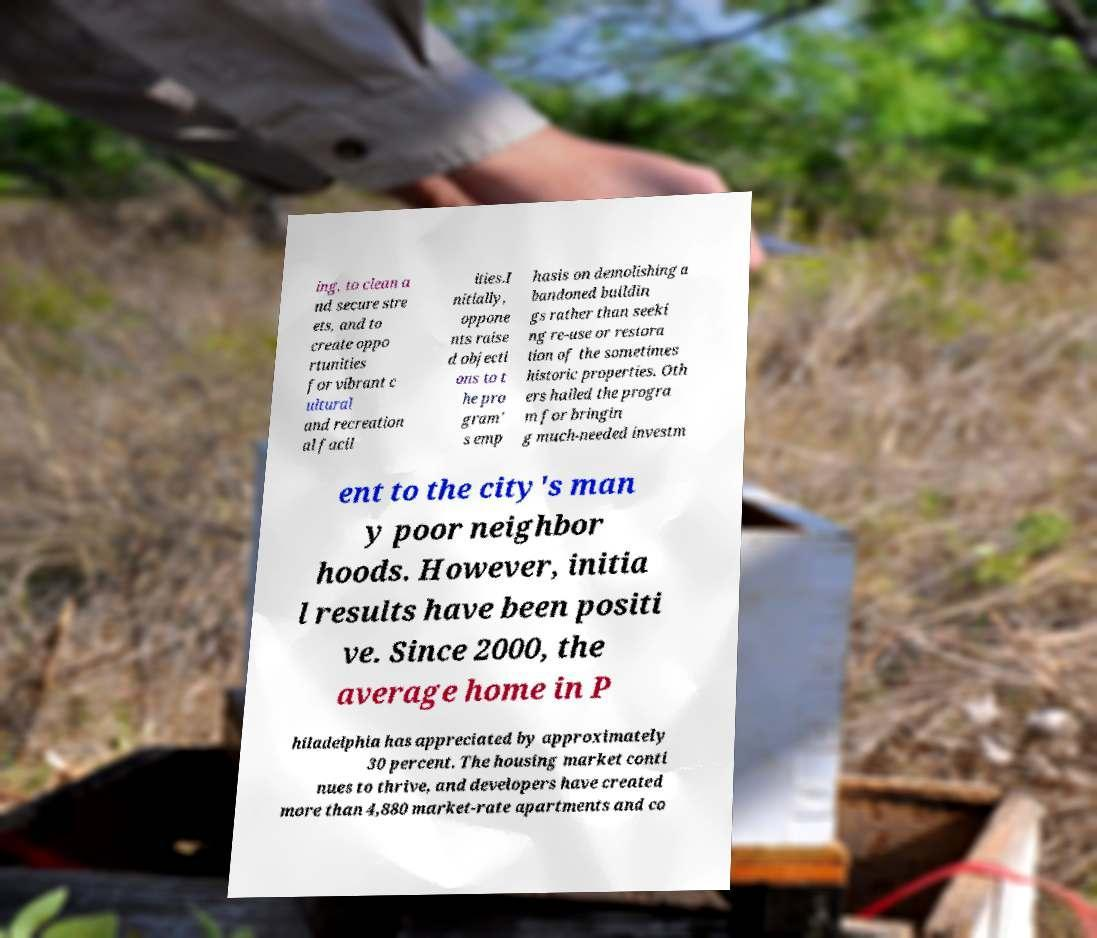There's text embedded in this image that I need extracted. Can you transcribe it verbatim? ing, to clean a nd secure stre ets, and to create oppo rtunities for vibrant c ultural and recreation al facil ities.I nitially, oppone nts raise d objecti ons to t he pro gram' s emp hasis on demolishing a bandoned buildin gs rather than seeki ng re-use or restora tion of the sometimes historic properties. Oth ers hailed the progra m for bringin g much-needed investm ent to the city's man y poor neighbor hoods. However, initia l results have been positi ve. Since 2000, the average home in P hiladelphia has appreciated by approximately 30 percent. The housing market conti nues to thrive, and developers have created more than 4,880 market-rate apartments and co 